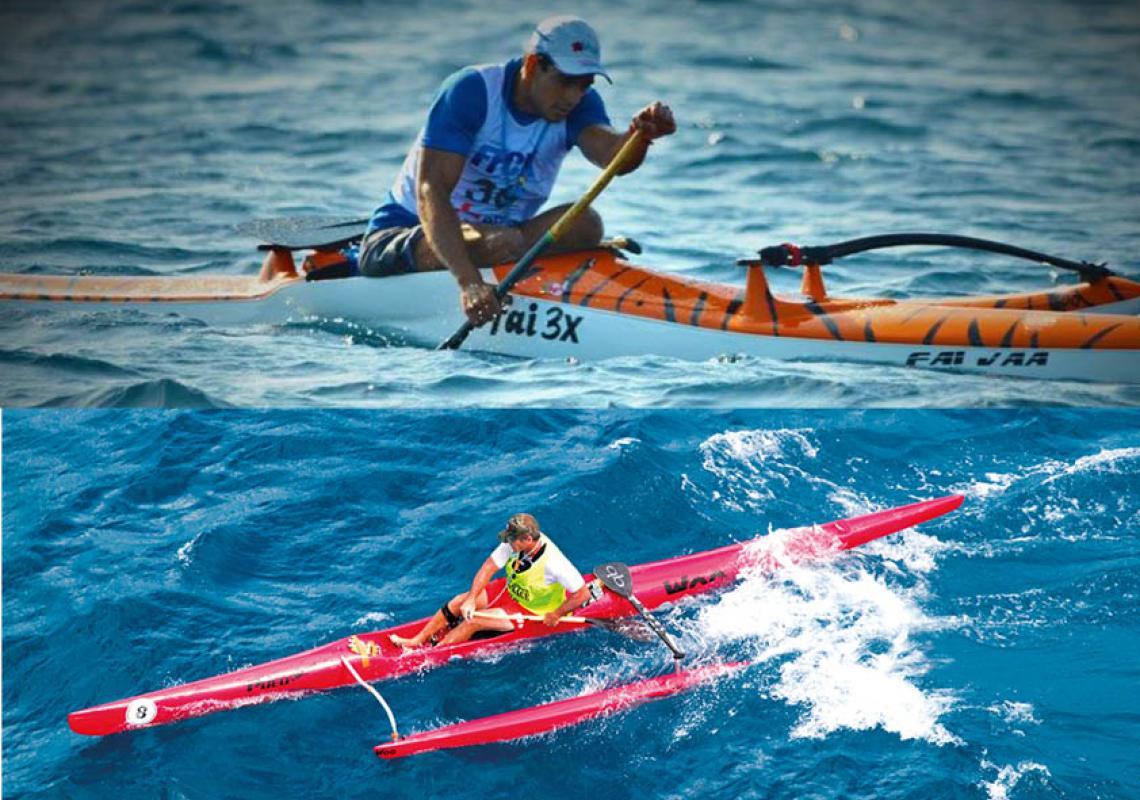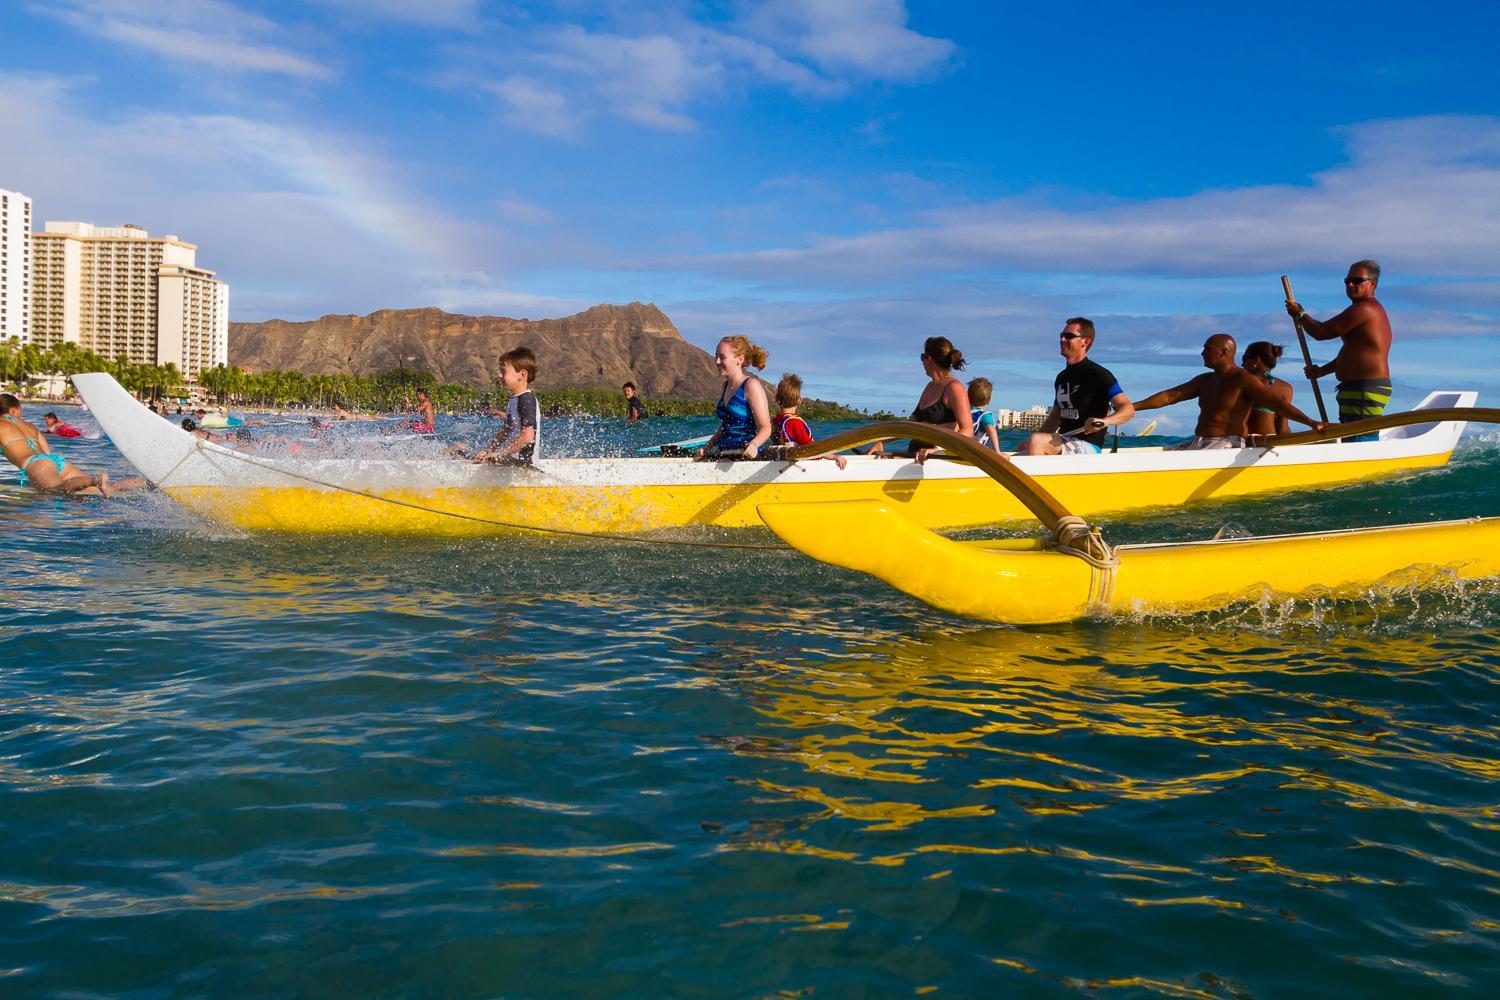The first image is the image on the left, the second image is the image on the right. Analyze the images presented: Is the assertion "An image shows just one bright yellow watercraft with riders." valid? Answer yes or no. Yes. 